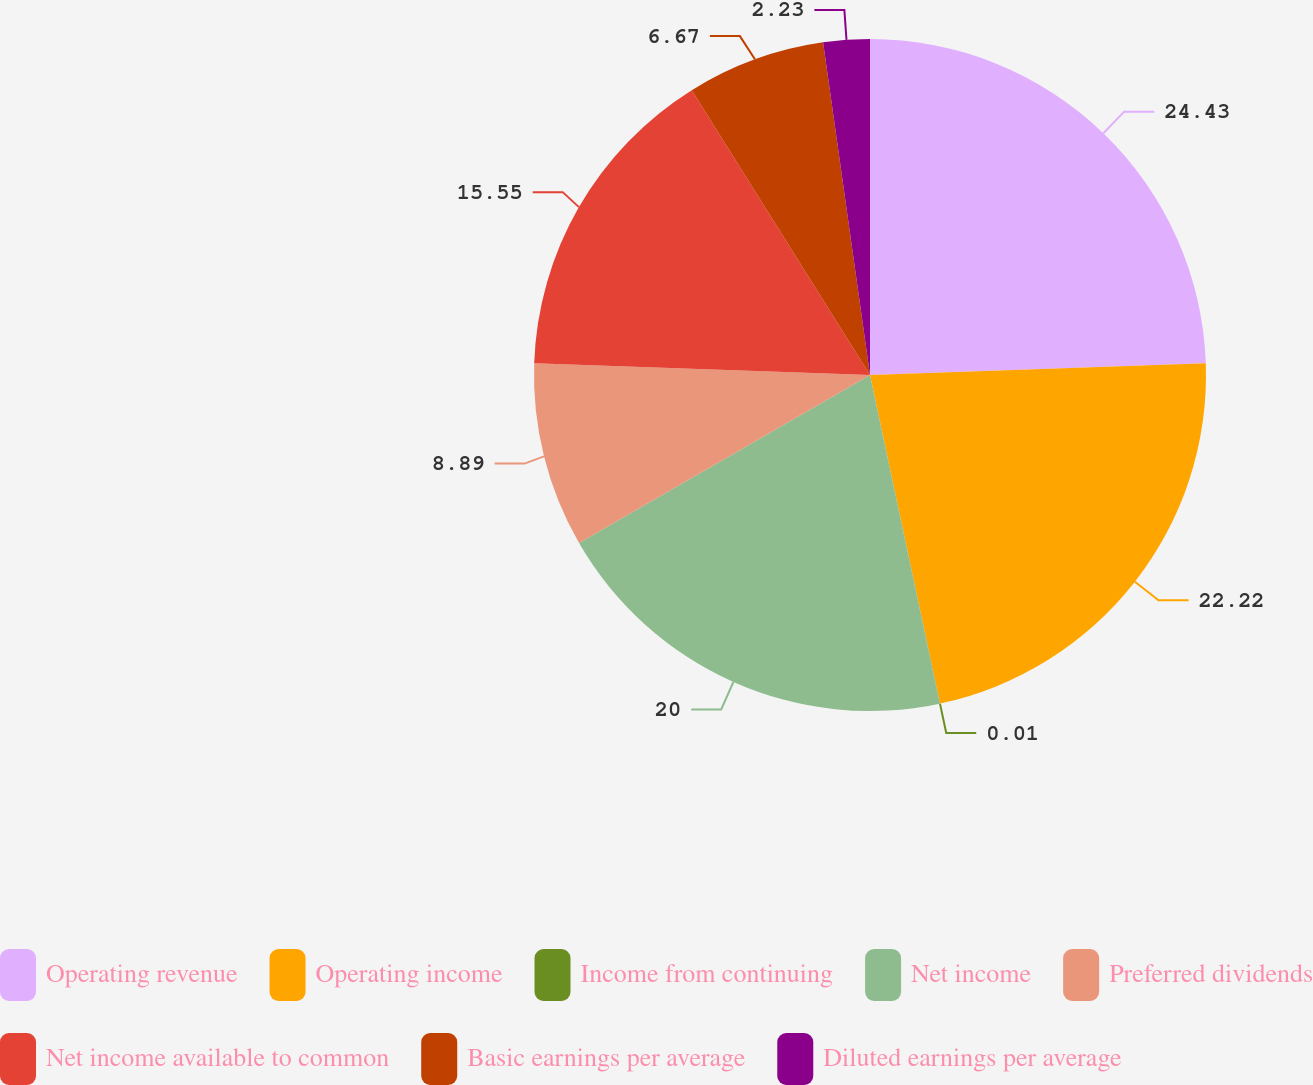Convert chart to OTSL. <chart><loc_0><loc_0><loc_500><loc_500><pie_chart><fcel>Operating revenue<fcel>Operating income<fcel>Income from continuing<fcel>Net income<fcel>Preferred dividends<fcel>Net income available to common<fcel>Basic earnings per average<fcel>Diluted earnings per average<nl><fcel>24.44%<fcel>22.22%<fcel>0.01%<fcel>20.0%<fcel>8.89%<fcel>15.55%<fcel>6.67%<fcel>2.23%<nl></chart> 